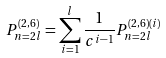Convert formula to latex. <formula><loc_0><loc_0><loc_500><loc_500>P _ { n = 2 l } ^ { ( 2 , 6 ) } = \sum _ { i = 1 } ^ { l } \frac { 1 } { c ^ { i - 1 } } P _ { n = 2 l } ^ { ( 2 , 6 ) ( i ) }</formula> 